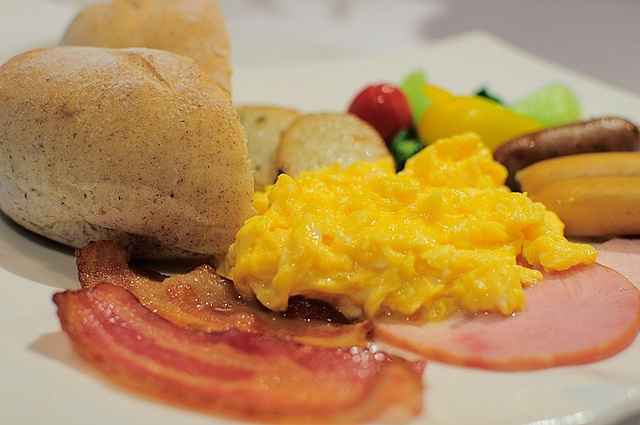Describe the objects in this image and their specific colors. I can see banana in lightgray, orange, red, and tan tones and hot dog in lightgray, maroon, gray, brown, and black tones in this image. 